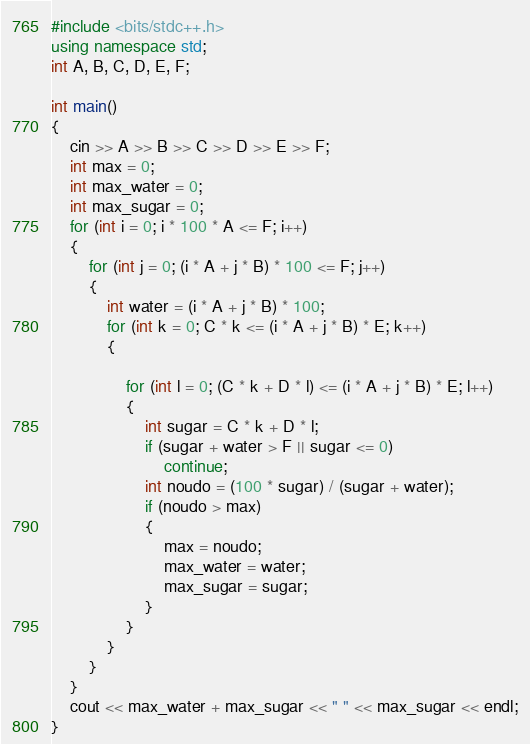<code> <loc_0><loc_0><loc_500><loc_500><_C++_>#include <bits/stdc++.h>
using namespace std;
int A, B, C, D, E, F;

int main()
{
    cin >> A >> B >> C >> D >> E >> F;
    int max = 0;
    int max_water = 0;
    int max_sugar = 0;
    for (int i = 0; i * 100 * A <= F; i++)
    {
        for (int j = 0; (i * A + j * B) * 100 <= F; j++)
        {
            int water = (i * A + j * B) * 100;
            for (int k = 0; C * k <= (i * A + j * B) * E; k++)
            {
                
                for (int l = 0; (C * k + D * l) <= (i * A + j * B) * E; l++)
                {
                    int sugar = C * k + D * l;
                    if (sugar + water > F || sugar <= 0)
                        continue;
                    int noudo = (100 * sugar) / (sugar + water);
                    if (noudo > max)
                    {
                        max = noudo;
                        max_water = water;
                        max_sugar = sugar;
                    }
                }
            }
        }
    }
    cout << max_water + max_sugar << " " << max_sugar << endl;
}</code> 